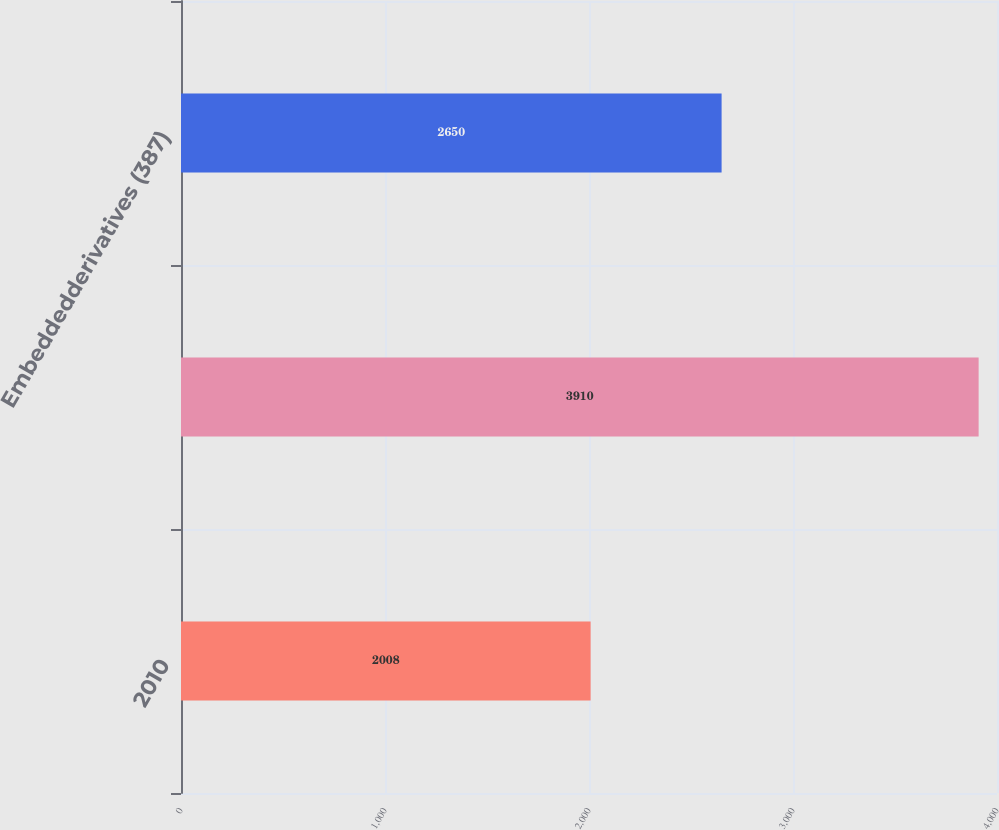Convert chart. <chart><loc_0><loc_0><loc_500><loc_500><bar_chart><fcel>2010<fcel>Unnamed: 1<fcel>Embeddedderivatives (387)<nl><fcel>2008<fcel>3910<fcel>2650<nl></chart> 